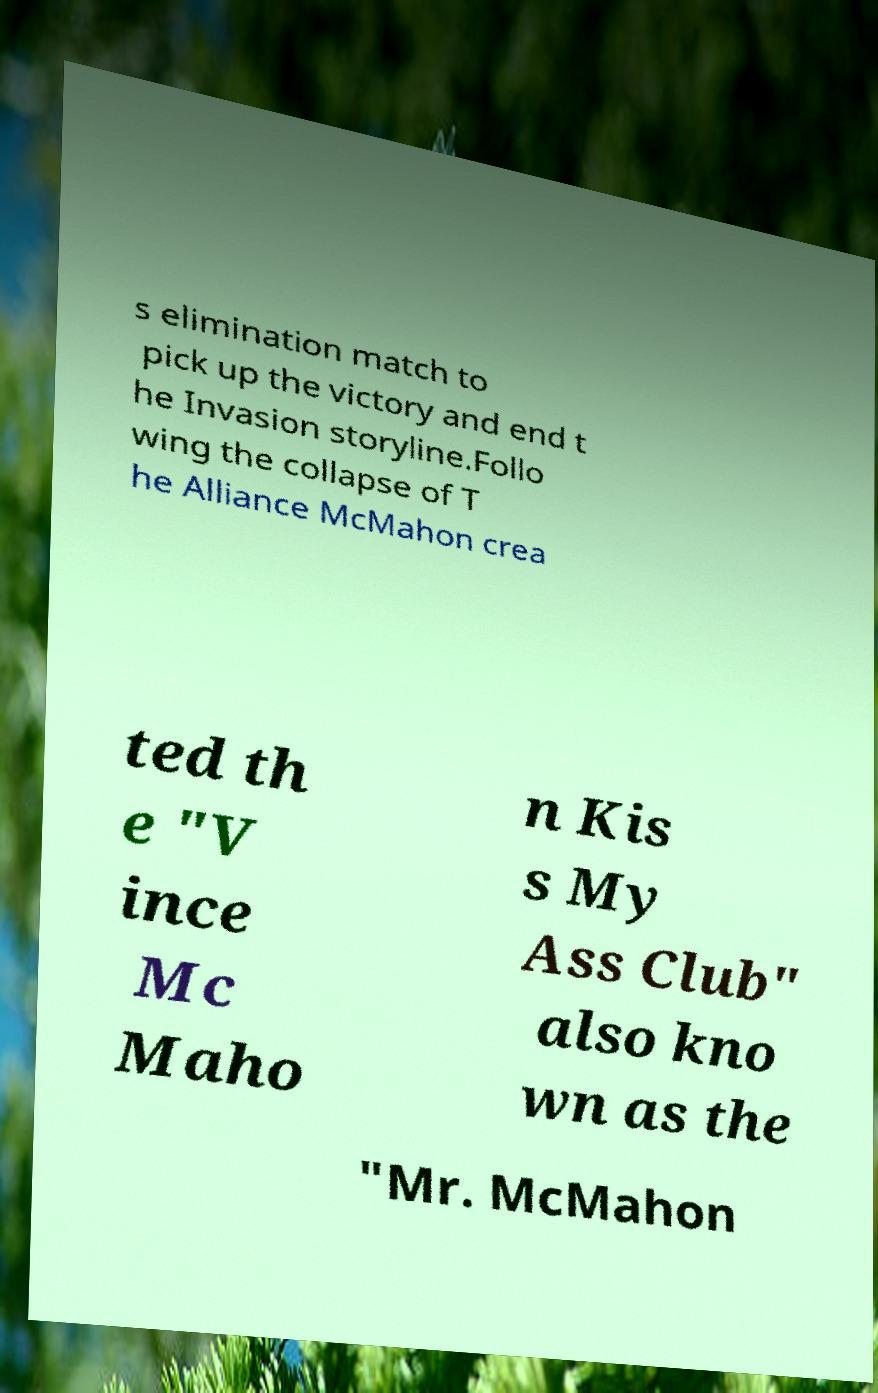Could you extract and type out the text from this image? s elimination match to pick up the victory and end t he Invasion storyline.Follo wing the collapse of T he Alliance McMahon crea ted th e "V ince Mc Maho n Kis s My Ass Club" also kno wn as the "Mr. McMahon 